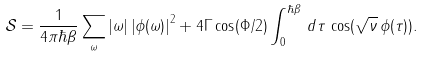Convert formula to latex. <formula><loc_0><loc_0><loc_500><loc_500>\mathcal { S } = \frac { 1 } { 4 \pi \hbar { \beta } } \sum _ { \omega } | \omega | \left | \phi ( \omega ) \right | ^ { 2 } + 4 \Gamma \cos ( \Phi / 2 ) \int _ { 0 } ^ { \hbar { \beta } } \, d \tau \, \cos ( \sqrt { \nu } \, \phi ( \tau ) ) .</formula> 